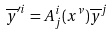Convert formula to latex. <formula><loc_0><loc_0><loc_500><loc_500>\overline { y } ^ { \prime i } = A _ { j } ^ { i } ( x ^ { \nu } ) \overline { y } ^ { j }</formula> 